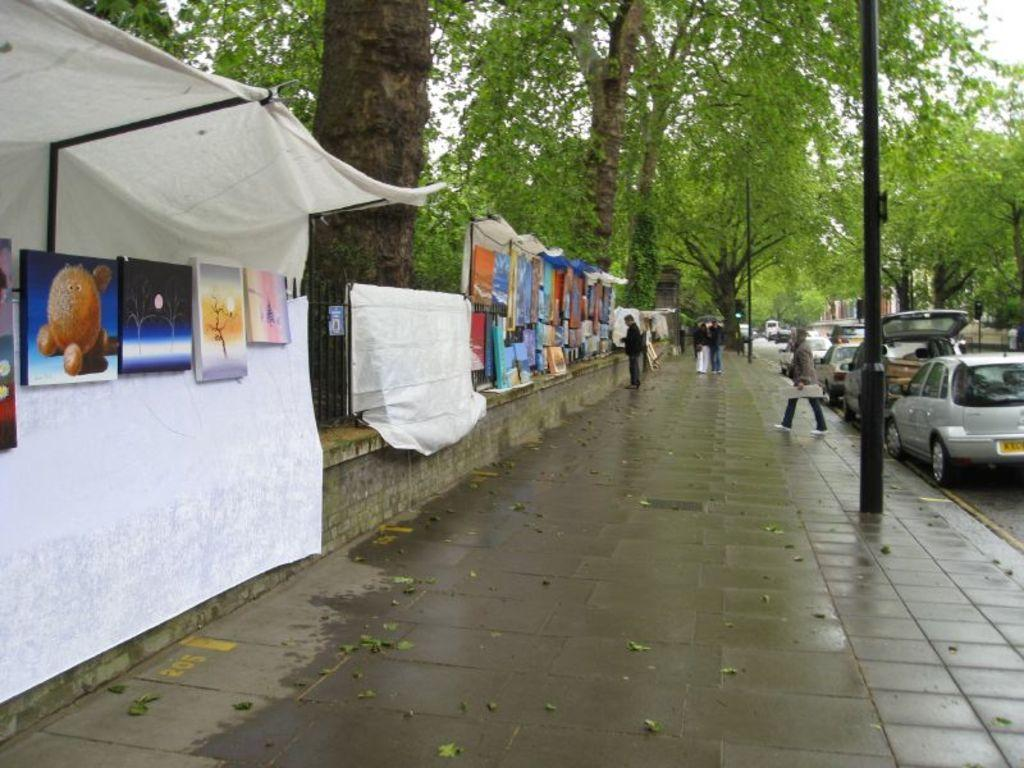What objects are present in the image that have a frame-like structure? There are frames in the image. What type of items can be seen in the image related to clothing? There are clothes in the image. Who or what can be seen in the image that is not an object or structure? There are people in the image. What type of transportation is visible in the image? There are vehicles in the image. What type of natural vegetation is present in the image? There are trees in the image. Can you tell me where the writer is sitting in the image? There is no writer present in the image. How many girls can be seen playing with the vehicles in the image? There is no girl present in the image. 